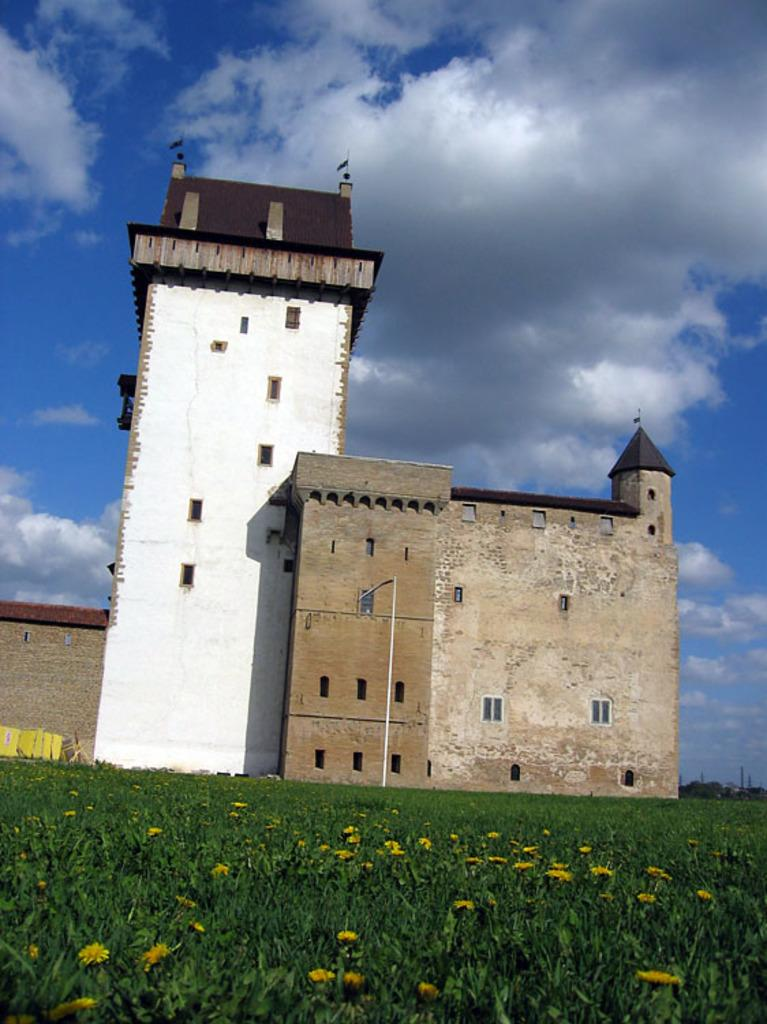What type of structure is present in the picture? There is a building in the picture. What else can be seen in the picture besides the building? There are flower plants in the picture. Are there any decorations or symbols on the building? Yes, there are flags on the building. What can be seen in the background of the picture? The sky is visible in the background of the picture. What type of fan is used to cool down the flowers in the picture? There is no fan present in the picture, and the flowers do not require cooling down. 